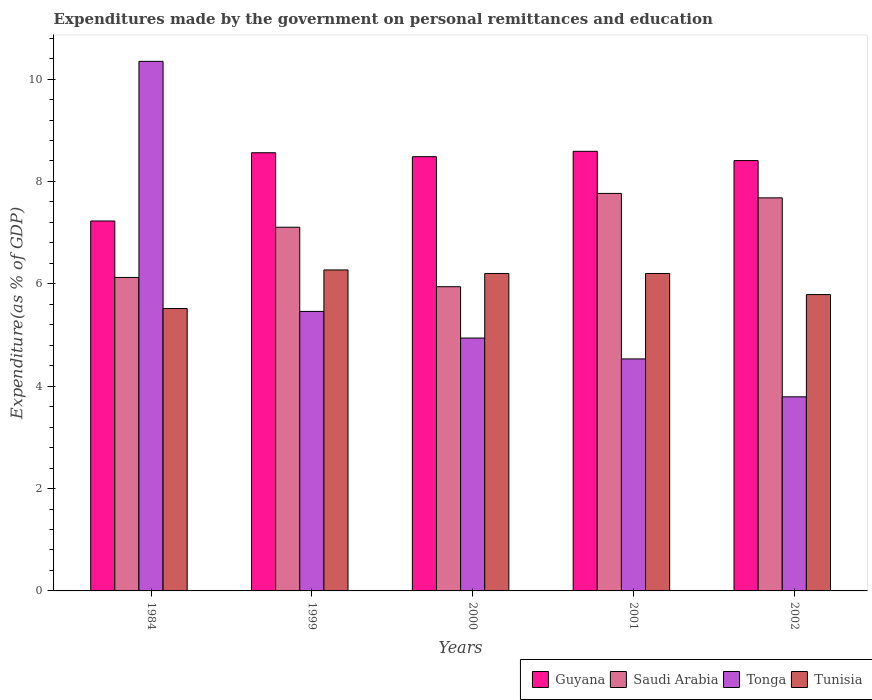How many groups of bars are there?
Your answer should be compact. 5. How many bars are there on the 1st tick from the right?
Provide a short and direct response. 4. What is the label of the 3rd group of bars from the left?
Keep it short and to the point. 2000. In how many cases, is the number of bars for a given year not equal to the number of legend labels?
Your response must be concise. 0. What is the expenditures made by the government on personal remittances and education in Tonga in 1999?
Ensure brevity in your answer.  5.46. Across all years, what is the maximum expenditures made by the government on personal remittances and education in Tonga?
Offer a very short reply. 10.35. Across all years, what is the minimum expenditures made by the government on personal remittances and education in Saudi Arabia?
Make the answer very short. 5.94. In which year was the expenditures made by the government on personal remittances and education in Tonga maximum?
Keep it short and to the point. 1984. What is the total expenditures made by the government on personal remittances and education in Guyana in the graph?
Offer a very short reply. 41.27. What is the difference between the expenditures made by the government on personal remittances and education in Tunisia in 1999 and that in 2001?
Your answer should be very brief. 0.07. What is the difference between the expenditures made by the government on personal remittances and education in Saudi Arabia in 2000 and the expenditures made by the government on personal remittances and education in Guyana in 2002?
Your answer should be compact. -2.46. What is the average expenditures made by the government on personal remittances and education in Saudi Arabia per year?
Your answer should be compact. 6.92. In the year 2001, what is the difference between the expenditures made by the government on personal remittances and education in Tunisia and expenditures made by the government on personal remittances and education in Saudi Arabia?
Keep it short and to the point. -1.56. In how many years, is the expenditures made by the government on personal remittances and education in Saudi Arabia greater than 3.6 %?
Make the answer very short. 5. What is the ratio of the expenditures made by the government on personal remittances and education in Guyana in 1999 to that in 2000?
Offer a very short reply. 1.01. What is the difference between the highest and the second highest expenditures made by the government on personal remittances and education in Tunisia?
Your answer should be very brief. 0.07. What is the difference between the highest and the lowest expenditures made by the government on personal remittances and education in Tunisia?
Your answer should be compact. 0.75. Is the sum of the expenditures made by the government on personal remittances and education in Guyana in 1999 and 2002 greater than the maximum expenditures made by the government on personal remittances and education in Saudi Arabia across all years?
Ensure brevity in your answer.  Yes. Is it the case that in every year, the sum of the expenditures made by the government on personal remittances and education in Guyana and expenditures made by the government on personal remittances and education in Tunisia is greater than the sum of expenditures made by the government on personal remittances and education in Saudi Arabia and expenditures made by the government on personal remittances and education in Tonga?
Provide a short and direct response. No. What does the 4th bar from the left in 1984 represents?
Your response must be concise. Tunisia. What does the 4th bar from the right in 2000 represents?
Your answer should be compact. Guyana. Are all the bars in the graph horizontal?
Ensure brevity in your answer.  No. What is the difference between two consecutive major ticks on the Y-axis?
Make the answer very short. 2. Are the values on the major ticks of Y-axis written in scientific E-notation?
Keep it short and to the point. No. Does the graph contain grids?
Make the answer very short. No. How many legend labels are there?
Offer a very short reply. 4. How are the legend labels stacked?
Keep it short and to the point. Horizontal. What is the title of the graph?
Ensure brevity in your answer.  Expenditures made by the government on personal remittances and education. What is the label or title of the Y-axis?
Provide a short and direct response. Expenditure(as % of GDP). What is the Expenditure(as % of GDP) in Guyana in 1984?
Offer a very short reply. 7.23. What is the Expenditure(as % of GDP) in Saudi Arabia in 1984?
Ensure brevity in your answer.  6.12. What is the Expenditure(as % of GDP) in Tonga in 1984?
Ensure brevity in your answer.  10.35. What is the Expenditure(as % of GDP) in Tunisia in 1984?
Your answer should be compact. 5.52. What is the Expenditure(as % of GDP) in Guyana in 1999?
Your answer should be compact. 8.56. What is the Expenditure(as % of GDP) of Saudi Arabia in 1999?
Make the answer very short. 7.11. What is the Expenditure(as % of GDP) in Tonga in 1999?
Ensure brevity in your answer.  5.46. What is the Expenditure(as % of GDP) in Tunisia in 1999?
Your response must be concise. 6.27. What is the Expenditure(as % of GDP) of Guyana in 2000?
Make the answer very short. 8.48. What is the Expenditure(as % of GDP) of Saudi Arabia in 2000?
Your answer should be very brief. 5.94. What is the Expenditure(as % of GDP) in Tonga in 2000?
Offer a terse response. 4.94. What is the Expenditure(as % of GDP) in Tunisia in 2000?
Provide a succinct answer. 6.2. What is the Expenditure(as % of GDP) in Guyana in 2001?
Offer a very short reply. 8.59. What is the Expenditure(as % of GDP) in Saudi Arabia in 2001?
Offer a terse response. 7.77. What is the Expenditure(as % of GDP) in Tonga in 2001?
Provide a succinct answer. 4.53. What is the Expenditure(as % of GDP) in Tunisia in 2001?
Provide a succinct answer. 6.2. What is the Expenditure(as % of GDP) of Guyana in 2002?
Provide a succinct answer. 8.41. What is the Expenditure(as % of GDP) of Saudi Arabia in 2002?
Ensure brevity in your answer.  7.68. What is the Expenditure(as % of GDP) in Tonga in 2002?
Make the answer very short. 3.79. What is the Expenditure(as % of GDP) in Tunisia in 2002?
Your answer should be compact. 5.79. Across all years, what is the maximum Expenditure(as % of GDP) of Guyana?
Make the answer very short. 8.59. Across all years, what is the maximum Expenditure(as % of GDP) in Saudi Arabia?
Offer a terse response. 7.77. Across all years, what is the maximum Expenditure(as % of GDP) of Tonga?
Keep it short and to the point. 10.35. Across all years, what is the maximum Expenditure(as % of GDP) in Tunisia?
Ensure brevity in your answer.  6.27. Across all years, what is the minimum Expenditure(as % of GDP) of Guyana?
Your response must be concise. 7.23. Across all years, what is the minimum Expenditure(as % of GDP) of Saudi Arabia?
Your answer should be very brief. 5.94. Across all years, what is the minimum Expenditure(as % of GDP) of Tonga?
Make the answer very short. 3.79. Across all years, what is the minimum Expenditure(as % of GDP) in Tunisia?
Your answer should be very brief. 5.52. What is the total Expenditure(as % of GDP) in Guyana in the graph?
Keep it short and to the point. 41.27. What is the total Expenditure(as % of GDP) of Saudi Arabia in the graph?
Your response must be concise. 34.62. What is the total Expenditure(as % of GDP) of Tonga in the graph?
Provide a short and direct response. 29.07. What is the total Expenditure(as % of GDP) in Tunisia in the graph?
Provide a succinct answer. 29.98. What is the difference between the Expenditure(as % of GDP) of Guyana in 1984 and that in 1999?
Give a very brief answer. -1.33. What is the difference between the Expenditure(as % of GDP) in Saudi Arabia in 1984 and that in 1999?
Give a very brief answer. -0.98. What is the difference between the Expenditure(as % of GDP) of Tonga in 1984 and that in 1999?
Ensure brevity in your answer.  4.89. What is the difference between the Expenditure(as % of GDP) in Tunisia in 1984 and that in 1999?
Offer a very short reply. -0.75. What is the difference between the Expenditure(as % of GDP) in Guyana in 1984 and that in 2000?
Provide a succinct answer. -1.26. What is the difference between the Expenditure(as % of GDP) of Saudi Arabia in 1984 and that in 2000?
Ensure brevity in your answer.  0.18. What is the difference between the Expenditure(as % of GDP) in Tonga in 1984 and that in 2000?
Offer a very short reply. 5.41. What is the difference between the Expenditure(as % of GDP) of Tunisia in 1984 and that in 2000?
Offer a terse response. -0.68. What is the difference between the Expenditure(as % of GDP) in Guyana in 1984 and that in 2001?
Offer a terse response. -1.36. What is the difference between the Expenditure(as % of GDP) of Saudi Arabia in 1984 and that in 2001?
Your response must be concise. -1.64. What is the difference between the Expenditure(as % of GDP) in Tonga in 1984 and that in 2001?
Your answer should be very brief. 5.81. What is the difference between the Expenditure(as % of GDP) in Tunisia in 1984 and that in 2001?
Offer a terse response. -0.68. What is the difference between the Expenditure(as % of GDP) of Guyana in 1984 and that in 2002?
Ensure brevity in your answer.  -1.18. What is the difference between the Expenditure(as % of GDP) in Saudi Arabia in 1984 and that in 2002?
Provide a short and direct response. -1.56. What is the difference between the Expenditure(as % of GDP) of Tonga in 1984 and that in 2002?
Offer a very short reply. 6.55. What is the difference between the Expenditure(as % of GDP) of Tunisia in 1984 and that in 2002?
Your answer should be very brief. -0.27. What is the difference between the Expenditure(as % of GDP) of Guyana in 1999 and that in 2000?
Your response must be concise. 0.08. What is the difference between the Expenditure(as % of GDP) of Saudi Arabia in 1999 and that in 2000?
Give a very brief answer. 1.16. What is the difference between the Expenditure(as % of GDP) in Tonga in 1999 and that in 2000?
Give a very brief answer. 0.52. What is the difference between the Expenditure(as % of GDP) in Tunisia in 1999 and that in 2000?
Give a very brief answer. 0.07. What is the difference between the Expenditure(as % of GDP) in Guyana in 1999 and that in 2001?
Keep it short and to the point. -0.03. What is the difference between the Expenditure(as % of GDP) of Saudi Arabia in 1999 and that in 2001?
Offer a very short reply. -0.66. What is the difference between the Expenditure(as % of GDP) of Tonga in 1999 and that in 2001?
Offer a terse response. 0.93. What is the difference between the Expenditure(as % of GDP) in Tunisia in 1999 and that in 2001?
Offer a very short reply. 0.07. What is the difference between the Expenditure(as % of GDP) in Guyana in 1999 and that in 2002?
Provide a short and direct response. 0.15. What is the difference between the Expenditure(as % of GDP) of Saudi Arabia in 1999 and that in 2002?
Keep it short and to the point. -0.57. What is the difference between the Expenditure(as % of GDP) in Tonga in 1999 and that in 2002?
Make the answer very short. 1.67. What is the difference between the Expenditure(as % of GDP) of Tunisia in 1999 and that in 2002?
Provide a short and direct response. 0.48. What is the difference between the Expenditure(as % of GDP) of Guyana in 2000 and that in 2001?
Your response must be concise. -0.1. What is the difference between the Expenditure(as % of GDP) in Saudi Arabia in 2000 and that in 2001?
Provide a succinct answer. -1.82. What is the difference between the Expenditure(as % of GDP) of Tonga in 2000 and that in 2001?
Your response must be concise. 0.41. What is the difference between the Expenditure(as % of GDP) in Guyana in 2000 and that in 2002?
Provide a short and direct response. 0.08. What is the difference between the Expenditure(as % of GDP) in Saudi Arabia in 2000 and that in 2002?
Make the answer very short. -1.74. What is the difference between the Expenditure(as % of GDP) of Tonga in 2000 and that in 2002?
Provide a short and direct response. 1.15. What is the difference between the Expenditure(as % of GDP) in Tunisia in 2000 and that in 2002?
Ensure brevity in your answer.  0.41. What is the difference between the Expenditure(as % of GDP) in Guyana in 2001 and that in 2002?
Your answer should be very brief. 0.18. What is the difference between the Expenditure(as % of GDP) of Saudi Arabia in 2001 and that in 2002?
Offer a very short reply. 0.09. What is the difference between the Expenditure(as % of GDP) of Tonga in 2001 and that in 2002?
Keep it short and to the point. 0.74. What is the difference between the Expenditure(as % of GDP) of Tunisia in 2001 and that in 2002?
Offer a terse response. 0.41. What is the difference between the Expenditure(as % of GDP) of Guyana in 1984 and the Expenditure(as % of GDP) of Saudi Arabia in 1999?
Offer a terse response. 0.12. What is the difference between the Expenditure(as % of GDP) of Guyana in 1984 and the Expenditure(as % of GDP) of Tonga in 1999?
Give a very brief answer. 1.77. What is the difference between the Expenditure(as % of GDP) of Guyana in 1984 and the Expenditure(as % of GDP) of Tunisia in 1999?
Offer a very short reply. 0.96. What is the difference between the Expenditure(as % of GDP) in Saudi Arabia in 1984 and the Expenditure(as % of GDP) in Tonga in 1999?
Give a very brief answer. 0.66. What is the difference between the Expenditure(as % of GDP) in Saudi Arabia in 1984 and the Expenditure(as % of GDP) in Tunisia in 1999?
Offer a very short reply. -0.15. What is the difference between the Expenditure(as % of GDP) in Tonga in 1984 and the Expenditure(as % of GDP) in Tunisia in 1999?
Your response must be concise. 4.08. What is the difference between the Expenditure(as % of GDP) of Guyana in 1984 and the Expenditure(as % of GDP) of Saudi Arabia in 2000?
Provide a succinct answer. 1.28. What is the difference between the Expenditure(as % of GDP) in Guyana in 1984 and the Expenditure(as % of GDP) in Tonga in 2000?
Offer a very short reply. 2.29. What is the difference between the Expenditure(as % of GDP) in Guyana in 1984 and the Expenditure(as % of GDP) in Tunisia in 2000?
Provide a succinct answer. 1.03. What is the difference between the Expenditure(as % of GDP) of Saudi Arabia in 1984 and the Expenditure(as % of GDP) of Tonga in 2000?
Your response must be concise. 1.18. What is the difference between the Expenditure(as % of GDP) in Saudi Arabia in 1984 and the Expenditure(as % of GDP) in Tunisia in 2000?
Your response must be concise. -0.08. What is the difference between the Expenditure(as % of GDP) of Tonga in 1984 and the Expenditure(as % of GDP) of Tunisia in 2000?
Your answer should be very brief. 4.14. What is the difference between the Expenditure(as % of GDP) in Guyana in 1984 and the Expenditure(as % of GDP) in Saudi Arabia in 2001?
Your response must be concise. -0.54. What is the difference between the Expenditure(as % of GDP) in Guyana in 1984 and the Expenditure(as % of GDP) in Tonga in 2001?
Your answer should be very brief. 2.69. What is the difference between the Expenditure(as % of GDP) of Guyana in 1984 and the Expenditure(as % of GDP) of Tunisia in 2001?
Offer a very short reply. 1.03. What is the difference between the Expenditure(as % of GDP) in Saudi Arabia in 1984 and the Expenditure(as % of GDP) in Tonga in 2001?
Make the answer very short. 1.59. What is the difference between the Expenditure(as % of GDP) in Saudi Arabia in 1984 and the Expenditure(as % of GDP) in Tunisia in 2001?
Make the answer very short. -0.08. What is the difference between the Expenditure(as % of GDP) in Tonga in 1984 and the Expenditure(as % of GDP) in Tunisia in 2001?
Offer a terse response. 4.14. What is the difference between the Expenditure(as % of GDP) of Guyana in 1984 and the Expenditure(as % of GDP) of Saudi Arabia in 2002?
Your answer should be very brief. -0.45. What is the difference between the Expenditure(as % of GDP) in Guyana in 1984 and the Expenditure(as % of GDP) in Tonga in 2002?
Make the answer very short. 3.44. What is the difference between the Expenditure(as % of GDP) of Guyana in 1984 and the Expenditure(as % of GDP) of Tunisia in 2002?
Provide a succinct answer. 1.44. What is the difference between the Expenditure(as % of GDP) of Saudi Arabia in 1984 and the Expenditure(as % of GDP) of Tonga in 2002?
Your answer should be compact. 2.33. What is the difference between the Expenditure(as % of GDP) in Saudi Arabia in 1984 and the Expenditure(as % of GDP) in Tunisia in 2002?
Provide a succinct answer. 0.33. What is the difference between the Expenditure(as % of GDP) of Tonga in 1984 and the Expenditure(as % of GDP) of Tunisia in 2002?
Provide a short and direct response. 4.56. What is the difference between the Expenditure(as % of GDP) in Guyana in 1999 and the Expenditure(as % of GDP) in Saudi Arabia in 2000?
Provide a succinct answer. 2.62. What is the difference between the Expenditure(as % of GDP) in Guyana in 1999 and the Expenditure(as % of GDP) in Tonga in 2000?
Provide a succinct answer. 3.62. What is the difference between the Expenditure(as % of GDP) in Guyana in 1999 and the Expenditure(as % of GDP) in Tunisia in 2000?
Give a very brief answer. 2.36. What is the difference between the Expenditure(as % of GDP) in Saudi Arabia in 1999 and the Expenditure(as % of GDP) in Tonga in 2000?
Offer a terse response. 2.16. What is the difference between the Expenditure(as % of GDP) of Saudi Arabia in 1999 and the Expenditure(as % of GDP) of Tunisia in 2000?
Ensure brevity in your answer.  0.9. What is the difference between the Expenditure(as % of GDP) in Tonga in 1999 and the Expenditure(as % of GDP) in Tunisia in 2000?
Provide a succinct answer. -0.74. What is the difference between the Expenditure(as % of GDP) in Guyana in 1999 and the Expenditure(as % of GDP) in Saudi Arabia in 2001?
Offer a terse response. 0.79. What is the difference between the Expenditure(as % of GDP) of Guyana in 1999 and the Expenditure(as % of GDP) of Tonga in 2001?
Make the answer very short. 4.03. What is the difference between the Expenditure(as % of GDP) of Guyana in 1999 and the Expenditure(as % of GDP) of Tunisia in 2001?
Keep it short and to the point. 2.36. What is the difference between the Expenditure(as % of GDP) of Saudi Arabia in 1999 and the Expenditure(as % of GDP) of Tonga in 2001?
Make the answer very short. 2.57. What is the difference between the Expenditure(as % of GDP) of Saudi Arabia in 1999 and the Expenditure(as % of GDP) of Tunisia in 2001?
Offer a terse response. 0.9. What is the difference between the Expenditure(as % of GDP) in Tonga in 1999 and the Expenditure(as % of GDP) in Tunisia in 2001?
Your answer should be compact. -0.74. What is the difference between the Expenditure(as % of GDP) in Guyana in 1999 and the Expenditure(as % of GDP) in Saudi Arabia in 2002?
Offer a very short reply. 0.88. What is the difference between the Expenditure(as % of GDP) in Guyana in 1999 and the Expenditure(as % of GDP) in Tonga in 2002?
Provide a succinct answer. 4.77. What is the difference between the Expenditure(as % of GDP) of Guyana in 1999 and the Expenditure(as % of GDP) of Tunisia in 2002?
Keep it short and to the point. 2.77. What is the difference between the Expenditure(as % of GDP) in Saudi Arabia in 1999 and the Expenditure(as % of GDP) in Tonga in 2002?
Offer a terse response. 3.31. What is the difference between the Expenditure(as % of GDP) in Saudi Arabia in 1999 and the Expenditure(as % of GDP) in Tunisia in 2002?
Offer a very short reply. 1.32. What is the difference between the Expenditure(as % of GDP) of Tonga in 1999 and the Expenditure(as % of GDP) of Tunisia in 2002?
Ensure brevity in your answer.  -0.33. What is the difference between the Expenditure(as % of GDP) of Guyana in 2000 and the Expenditure(as % of GDP) of Saudi Arabia in 2001?
Provide a succinct answer. 0.72. What is the difference between the Expenditure(as % of GDP) in Guyana in 2000 and the Expenditure(as % of GDP) in Tonga in 2001?
Offer a very short reply. 3.95. What is the difference between the Expenditure(as % of GDP) of Guyana in 2000 and the Expenditure(as % of GDP) of Tunisia in 2001?
Provide a short and direct response. 2.28. What is the difference between the Expenditure(as % of GDP) in Saudi Arabia in 2000 and the Expenditure(as % of GDP) in Tonga in 2001?
Make the answer very short. 1.41. What is the difference between the Expenditure(as % of GDP) in Saudi Arabia in 2000 and the Expenditure(as % of GDP) in Tunisia in 2001?
Your response must be concise. -0.26. What is the difference between the Expenditure(as % of GDP) in Tonga in 2000 and the Expenditure(as % of GDP) in Tunisia in 2001?
Your answer should be compact. -1.26. What is the difference between the Expenditure(as % of GDP) in Guyana in 2000 and the Expenditure(as % of GDP) in Saudi Arabia in 2002?
Make the answer very short. 0.8. What is the difference between the Expenditure(as % of GDP) in Guyana in 2000 and the Expenditure(as % of GDP) in Tonga in 2002?
Offer a terse response. 4.69. What is the difference between the Expenditure(as % of GDP) in Guyana in 2000 and the Expenditure(as % of GDP) in Tunisia in 2002?
Provide a succinct answer. 2.69. What is the difference between the Expenditure(as % of GDP) of Saudi Arabia in 2000 and the Expenditure(as % of GDP) of Tonga in 2002?
Provide a succinct answer. 2.15. What is the difference between the Expenditure(as % of GDP) of Saudi Arabia in 2000 and the Expenditure(as % of GDP) of Tunisia in 2002?
Offer a very short reply. 0.15. What is the difference between the Expenditure(as % of GDP) in Tonga in 2000 and the Expenditure(as % of GDP) in Tunisia in 2002?
Your response must be concise. -0.85. What is the difference between the Expenditure(as % of GDP) of Guyana in 2001 and the Expenditure(as % of GDP) of Saudi Arabia in 2002?
Ensure brevity in your answer.  0.91. What is the difference between the Expenditure(as % of GDP) of Guyana in 2001 and the Expenditure(as % of GDP) of Tonga in 2002?
Provide a short and direct response. 4.8. What is the difference between the Expenditure(as % of GDP) in Guyana in 2001 and the Expenditure(as % of GDP) in Tunisia in 2002?
Offer a terse response. 2.8. What is the difference between the Expenditure(as % of GDP) in Saudi Arabia in 2001 and the Expenditure(as % of GDP) in Tonga in 2002?
Provide a succinct answer. 3.97. What is the difference between the Expenditure(as % of GDP) in Saudi Arabia in 2001 and the Expenditure(as % of GDP) in Tunisia in 2002?
Provide a succinct answer. 1.98. What is the difference between the Expenditure(as % of GDP) in Tonga in 2001 and the Expenditure(as % of GDP) in Tunisia in 2002?
Ensure brevity in your answer.  -1.26. What is the average Expenditure(as % of GDP) of Guyana per year?
Ensure brevity in your answer.  8.25. What is the average Expenditure(as % of GDP) in Saudi Arabia per year?
Offer a terse response. 6.92. What is the average Expenditure(as % of GDP) of Tonga per year?
Offer a terse response. 5.81. What is the average Expenditure(as % of GDP) in Tunisia per year?
Your answer should be very brief. 6. In the year 1984, what is the difference between the Expenditure(as % of GDP) in Guyana and Expenditure(as % of GDP) in Saudi Arabia?
Provide a succinct answer. 1.1. In the year 1984, what is the difference between the Expenditure(as % of GDP) in Guyana and Expenditure(as % of GDP) in Tonga?
Keep it short and to the point. -3.12. In the year 1984, what is the difference between the Expenditure(as % of GDP) in Guyana and Expenditure(as % of GDP) in Tunisia?
Give a very brief answer. 1.71. In the year 1984, what is the difference between the Expenditure(as % of GDP) in Saudi Arabia and Expenditure(as % of GDP) in Tonga?
Give a very brief answer. -4.22. In the year 1984, what is the difference between the Expenditure(as % of GDP) of Saudi Arabia and Expenditure(as % of GDP) of Tunisia?
Your answer should be compact. 0.61. In the year 1984, what is the difference between the Expenditure(as % of GDP) in Tonga and Expenditure(as % of GDP) in Tunisia?
Offer a terse response. 4.83. In the year 1999, what is the difference between the Expenditure(as % of GDP) in Guyana and Expenditure(as % of GDP) in Saudi Arabia?
Make the answer very short. 1.46. In the year 1999, what is the difference between the Expenditure(as % of GDP) in Guyana and Expenditure(as % of GDP) in Tonga?
Offer a very short reply. 3.1. In the year 1999, what is the difference between the Expenditure(as % of GDP) of Guyana and Expenditure(as % of GDP) of Tunisia?
Make the answer very short. 2.29. In the year 1999, what is the difference between the Expenditure(as % of GDP) of Saudi Arabia and Expenditure(as % of GDP) of Tonga?
Your response must be concise. 1.64. In the year 1999, what is the difference between the Expenditure(as % of GDP) in Saudi Arabia and Expenditure(as % of GDP) in Tunisia?
Your answer should be compact. 0.83. In the year 1999, what is the difference between the Expenditure(as % of GDP) of Tonga and Expenditure(as % of GDP) of Tunisia?
Your answer should be very brief. -0.81. In the year 2000, what is the difference between the Expenditure(as % of GDP) in Guyana and Expenditure(as % of GDP) in Saudi Arabia?
Offer a terse response. 2.54. In the year 2000, what is the difference between the Expenditure(as % of GDP) in Guyana and Expenditure(as % of GDP) in Tonga?
Your answer should be very brief. 3.54. In the year 2000, what is the difference between the Expenditure(as % of GDP) in Guyana and Expenditure(as % of GDP) in Tunisia?
Keep it short and to the point. 2.28. In the year 2000, what is the difference between the Expenditure(as % of GDP) of Saudi Arabia and Expenditure(as % of GDP) of Tonga?
Offer a very short reply. 1. In the year 2000, what is the difference between the Expenditure(as % of GDP) in Saudi Arabia and Expenditure(as % of GDP) in Tunisia?
Ensure brevity in your answer.  -0.26. In the year 2000, what is the difference between the Expenditure(as % of GDP) in Tonga and Expenditure(as % of GDP) in Tunisia?
Ensure brevity in your answer.  -1.26. In the year 2001, what is the difference between the Expenditure(as % of GDP) in Guyana and Expenditure(as % of GDP) in Saudi Arabia?
Provide a succinct answer. 0.82. In the year 2001, what is the difference between the Expenditure(as % of GDP) in Guyana and Expenditure(as % of GDP) in Tonga?
Your answer should be compact. 4.06. In the year 2001, what is the difference between the Expenditure(as % of GDP) of Guyana and Expenditure(as % of GDP) of Tunisia?
Make the answer very short. 2.39. In the year 2001, what is the difference between the Expenditure(as % of GDP) of Saudi Arabia and Expenditure(as % of GDP) of Tonga?
Make the answer very short. 3.23. In the year 2001, what is the difference between the Expenditure(as % of GDP) of Saudi Arabia and Expenditure(as % of GDP) of Tunisia?
Offer a terse response. 1.56. In the year 2001, what is the difference between the Expenditure(as % of GDP) in Tonga and Expenditure(as % of GDP) in Tunisia?
Provide a succinct answer. -1.67. In the year 2002, what is the difference between the Expenditure(as % of GDP) of Guyana and Expenditure(as % of GDP) of Saudi Arabia?
Give a very brief answer. 0.73. In the year 2002, what is the difference between the Expenditure(as % of GDP) in Guyana and Expenditure(as % of GDP) in Tonga?
Offer a very short reply. 4.62. In the year 2002, what is the difference between the Expenditure(as % of GDP) in Guyana and Expenditure(as % of GDP) in Tunisia?
Give a very brief answer. 2.62. In the year 2002, what is the difference between the Expenditure(as % of GDP) of Saudi Arabia and Expenditure(as % of GDP) of Tonga?
Provide a short and direct response. 3.89. In the year 2002, what is the difference between the Expenditure(as % of GDP) of Saudi Arabia and Expenditure(as % of GDP) of Tunisia?
Give a very brief answer. 1.89. In the year 2002, what is the difference between the Expenditure(as % of GDP) of Tonga and Expenditure(as % of GDP) of Tunisia?
Your answer should be very brief. -2. What is the ratio of the Expenditure(as % of GDP) of Guyana in 1984 to that in 1999?
Ensure brevity in your answer.  0.84. What is the ratio of the Expenditure(as % of GDP) in Saudi Arabia in 1984 to that in 1999?
Your response must be concise. 0.86. What is the ratio of the Expenditure(as % of GDP) of Tonga in 1984 to that in 1999?
Offer a terse response. 1.89. What is the ratio of the Expenditure(as % of GDP) of Tunisia in 1984 to that in 1999?
Your answer should be compact. 0.88. What is the ratio of the Expenditure(as % of GDP) of Guyana in 1984 to that in 2000?
Ensure brevity in your answer.  0.85. What is the ratio of the Expenditure(as % of GDP) of Saudi Arabia in 1984 to that in 2000?
Offer a very short reply. 1.03. What is the ratio of the Expenditure(as % of GDP) of Tonga in 1984 to that in 2000?
Make the answer very short. 2.09. What is the ratio of the Expenditure(as % of GDP) in Tunisia in 1984 to that in 2000?
Make the answer very short. 0.89. What is the ratio of the Expenditure(as % of GDP) of Guyana in 1984 to that in 2001?
Offer a terse response. 0.84. What is the ratio of the Expenditure(as % of GDP) of Saudi Arabia in 1984 to that in 2001?
Keep it short and to the point. 0.79. What is the ratio of the Expenditure(as % of GDP) of Tonga in 1984 to that in 2001?
Offer a terse response. 2.28. What is the ratio of the Expenditure(as % of GDP) of Tunisia in 1984 to that in 2001?
Provide a succinct answer. 0.89. What is the ratio of the Expenditure(as % of GDP) of Guyana in 1984 to that in 2002?
Keep it short and to the point. 0.86. What is the ratio of the Expenditure(as % of GDP) in Saudi Arabia in 1984 to that in 2002?
Your answer should be compact. 0.8. What is the ratio of the Expenditure(as % of GDP) of Tonga in 1984 to that in 2002?
Your answer should be compact. 2.73. What is the ratio of the Expenditure(as % of GDP) of Tunisia in 1984 to that in 2002?
Keep it short and to the point. 0.95. What is the ratio of the Expenditure(as % of GDP) of Guyana in 1999 to that in 2000?
Offer a terse response. 1.01. What is the ratio of the Expenditure(as % of GDP) of Saudi Arabia in 1999 to that in 2000?
Your answer should be compact. 1.2. What is the ratio of the Expenditure(as % of GDP) of Tonga in 1999 to that in 2000?
Make the answer very short. 1.11. What is the ratio of the Expenditure(as % of GDP) in Tunisia in 1999 to that in 2000?
Make the answer very short. 1.01. What is the ratio of the Expenditure(as % of GDP) in Saudi Arabia in 1999 to that in 2001?
Make the answer very short. 0.91. What is the ratio of the Expenditure(as % of GDP) in Tonga in 1999 to that in 2001?
Your answer should be very brief. 1.2. What is the ratio of the Expenditure(as % of GDP) of Tunisia in 1999 to that in 2001?
Your response must be concise. 1.01. What is the ratio of the Expenditure(as % of GDP) of Guyana in 1999 to that in 2002?
Keep it short and to the point. 1.02. What is the ratio of the Expenditure(as % of GDP) of Saudi Arabia in 1999 to that in 2002?
Your response must be concise. 0.93. What is the ratio of the Expenditure(as % of GDP) of Tonga in 1999 to that in 2002?
Ensure brevity in your answer.  1.44. What is the ratio of the Expenditure(as % of GDP) in Tunisia in 1999 to that in 2002?
Your answer should be very brief. 1.08. What is the ratio of the Expenditure(as % of GDP) of Guyana in 2000 to that in 2001?
Provide a short and direct response. 0.99. What is the ratio of the Expenditure(as % of GDP) of Saudi Arabia in 2000 to that in 2001?
Give a very brief answer. 0.77. What is the ratio of the Expenditure(as % of GDP) of Tonga in 2000 to that in 2001?
Keep it short and to the point. 1.09. What is the ratio of the Expenditure(as % of GDP) of Tunisia in 2000 to that in 2001?
Ensure brevity in your answer.  1. What is the ratio of the Expenditure(as % of GDP) in Guyana in 2000 to that in 2002?
Provide a succinct answer. 1.01. What is the ratio of the Expenditure(as % of GDP) of Saudi Arabia in 2000 to that in 2002?
Provide a short and direct response. 0.77. What is the ratio of the Expenditure(as % of GDP) in Tonga in 2000 to that in 2002?
Offer a very short reply. 1.3. What is the ratio of the Expenditure(as % of GDP) in Tunisia in 2000 to that in 2002?
Offer a terse response. 1.07. What is the ratio of the Expenditure(as % of GDP) in Guyana in 2001 to that in 2002?
Give a very brief answer. 1.02. What is the ratio of the Expenditure(as % of GDP) in Saudi Arabia in 2001 to that in 2002?
Your answer should be compact. 1.01. What is the ratio of the Expenditure(as % of GDP) of Tonga in 2001 to that in 2002?
Provide a short and direct response. 1.2. What is the ratio of the Expenditure(as % of GDP) in Tunisia in 2001 to that in 2002?
Give a very brief answer. 1.07. What is the difference between the highest and the second highest Expenditure(as % of GDP) in Guyana?
Your answer should be very brief. 0.03. What is the difference between the highest and the second highest Expenditure(as % of GDP) in Saudi Arabia?
Offer a very short reply. 0.09. What is the difference between the highest and the second highest Expenditure(as % of GDP) in Tonga?
Keep it short and to the point. 4.89. What is the difference between the highest and the second highest Expenditure(as % of GDP) in Tunisia?
Provide a short and direct response. 0.07. What is the difference between the highest and the lowest Expenditure(as % of GDP) of Guyana?
Your answer should be very brief. 1.36. What is the difference between the highest and the lowest Expenditure(as % of GDP) in Saudi Arabia?
Ensure brevity in your answer.  1.82. What is the difference between the highest and the lowest Expenditure(as % of GDP) in Tonga?
Give a very brief answer. 6.55. What is the difference between the highest and the lowest Expenditure(as % of GDP) of Tunisia?
Give a very brief answer. 0.75. 